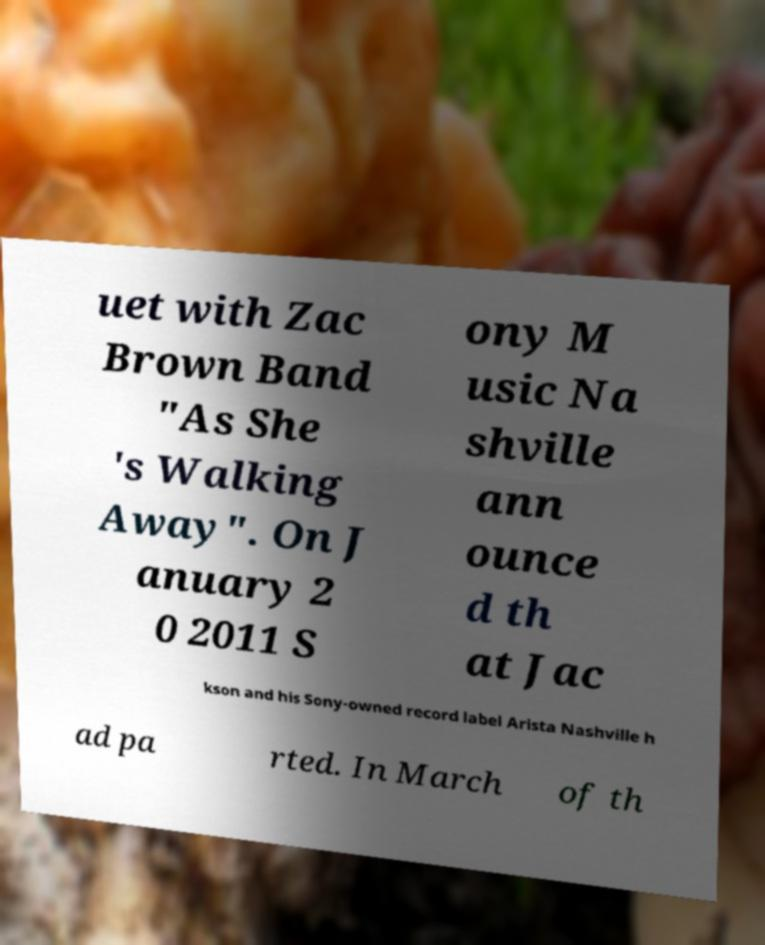Please read and relay the text visible in this image. What does it say? uet with Zac Brown Band "As She 's Walking Away". On J anuary 2 0 2011 S ony M usic Na shville ann ounce d th at Jac kson and his Sony-owned record label Arista Nashville h ad pa rted. In March of th 